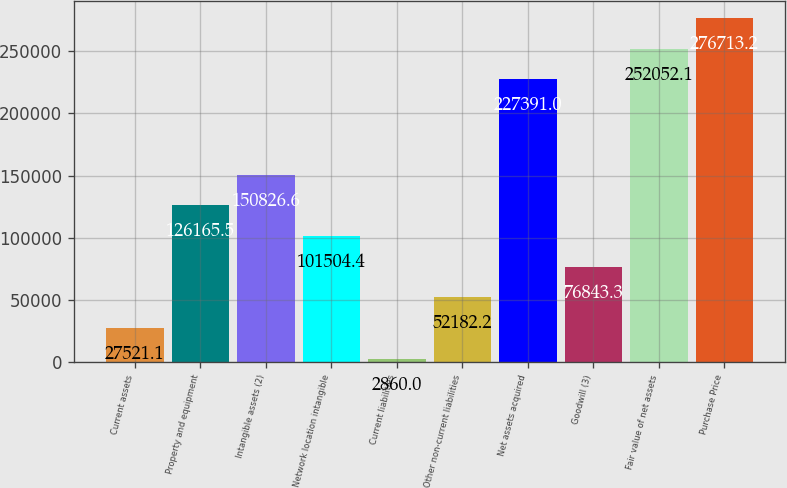Convert chart to OTSL. <chart><loc_0><loc_0><loc_500><loc_500><bar_chart><fcel>Current assets<fcel>Property and equipment<fcel>Intangible assets (2)<fcel>Network location intangible<fcel>Current liabilities<fcel>Other non-current liabilities<fcel>Net assets acquired<fcel>Goodwill (3)<fcel>Fair value of net assets<fcel>Purchase Price<nl><fcel>27521.1<fcel>126166<fcel>150827<fcel>101504<fcel>2860<fcel>52182.2<fcel>227391<fcel>76843.3<fcel>252052<fcel>276713<nl></chart> 